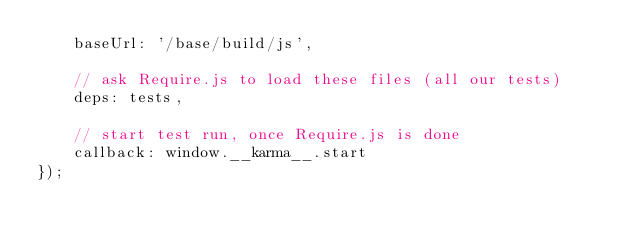Convert code to text. <code><loc_0><loc_0><loc_500><loc_500><_JavaScript_>    baseUrl: '/base/build/js',

    // ask Require.js to load these files (all our tests)
    deps: tests,

    // start test run, once Require.js is done
    callback: window.__karma__.start
});

</code> 